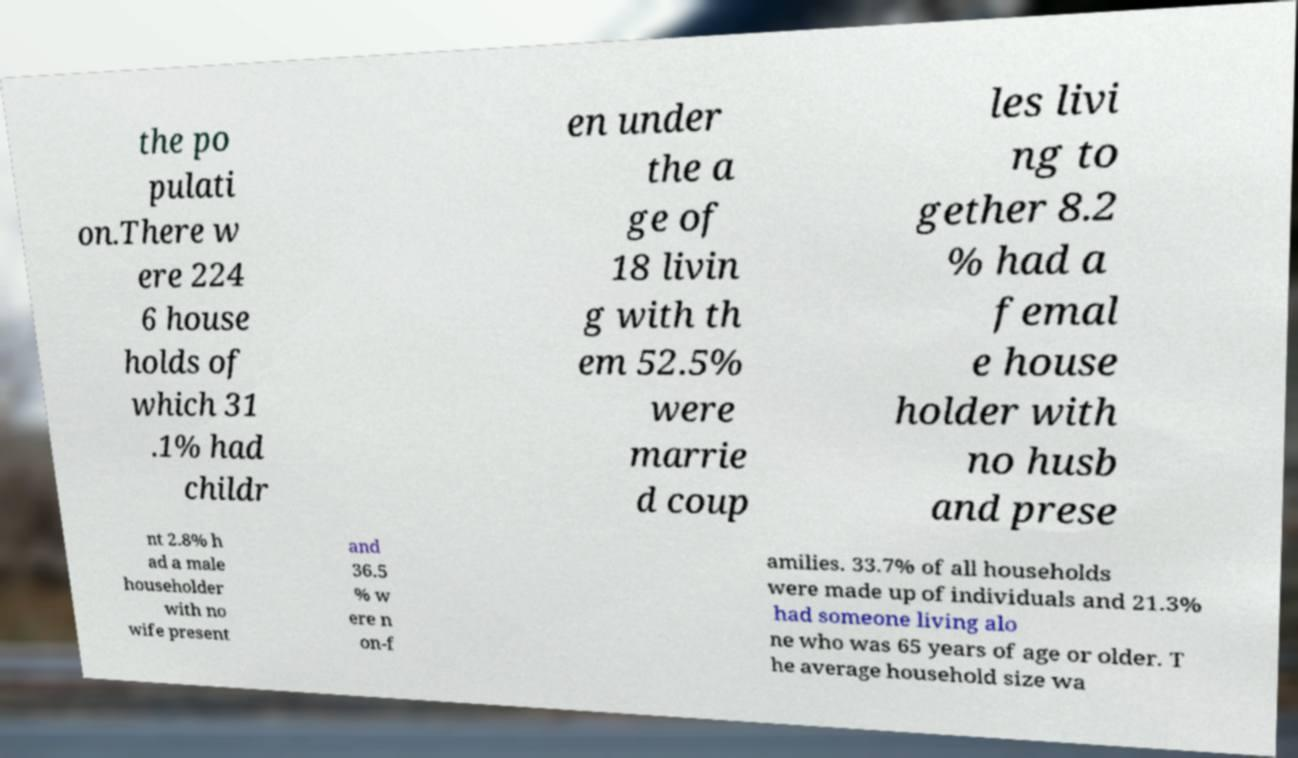Can you read and provide the text displayed in the image?This photo seems to have some interesting text. Can you extract and type it out for me? the po pulati on.There w ere 224 6 house holds of which 31 .1% had childr en under the a ge of 18 livin g with th em 52.5% were marrie d coup les livi ng to gether 8.2 % had a femal e house holder with no husb and prese nt 2.8% h ad a male householder with no wife present and 36.5 % w ere n on-f amilies. 33.7% of all households were made up of individuals and 21.3% had someone living alo ne who was 65 years of age or older. T he average household size wa 